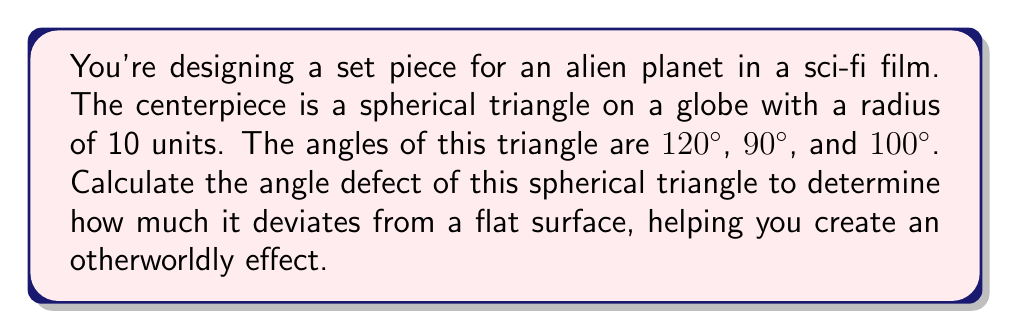Teach me how to tackle this problem. To calculate the angle defect of a spherical triangle, we'll follow these steps:

1) The angle defect is defined as the difference between the sum of the angles in a spherical triangle and the sum of angles in a planar triangle (which is always 180°).

2) Let's denote the angle defect as $\delta$. The formula is:

   $$\delta = (\alpha + \beta + \gamma) - 180°$$

   Where $\alpha$, $\beta$, and $\gamma$ are the angles of the spherical triangle.

3) Given angles: 120°, 90°, and 100°

4) Sum the angles:
   $$120° + 90° + 100° = 310°$$

5) Calculate the angle defect:
   $$\delta = 310° - 180° = 130°$$

6) The angle defect can also be related to the area $A$ of the spherical triangle:

   $$A = \delta R^2$$

   Where $R$ is the radius of the sphere.

7) With $R = 10$ units:
   $$A = 130° \cdot (\pi/180°) \cdot 10^2 = 226.89 \text{ square units}$$

This large angle defect and area demonstrate how significantly this triangle deviates from a flat surface, creating an otherworldly effect for your set piece.

[asy]
import geometry;

size(200);
draw(circle((0,0),1));
dot((0,0));

pair A = dir(30);
pair B = dir(150);
pair C = dir(270);

draw(Arc((0,0),A,B,CW));
draw(Arc((0,0),B,C,CW));
draw(Arc((0,0),C,A,CW));

label("120°", A, NE);
label("90°", B, NW);
label("100°", C, S);

dot(A);
dot(B);
dot(C);
[/asy]
Answer: 130° 